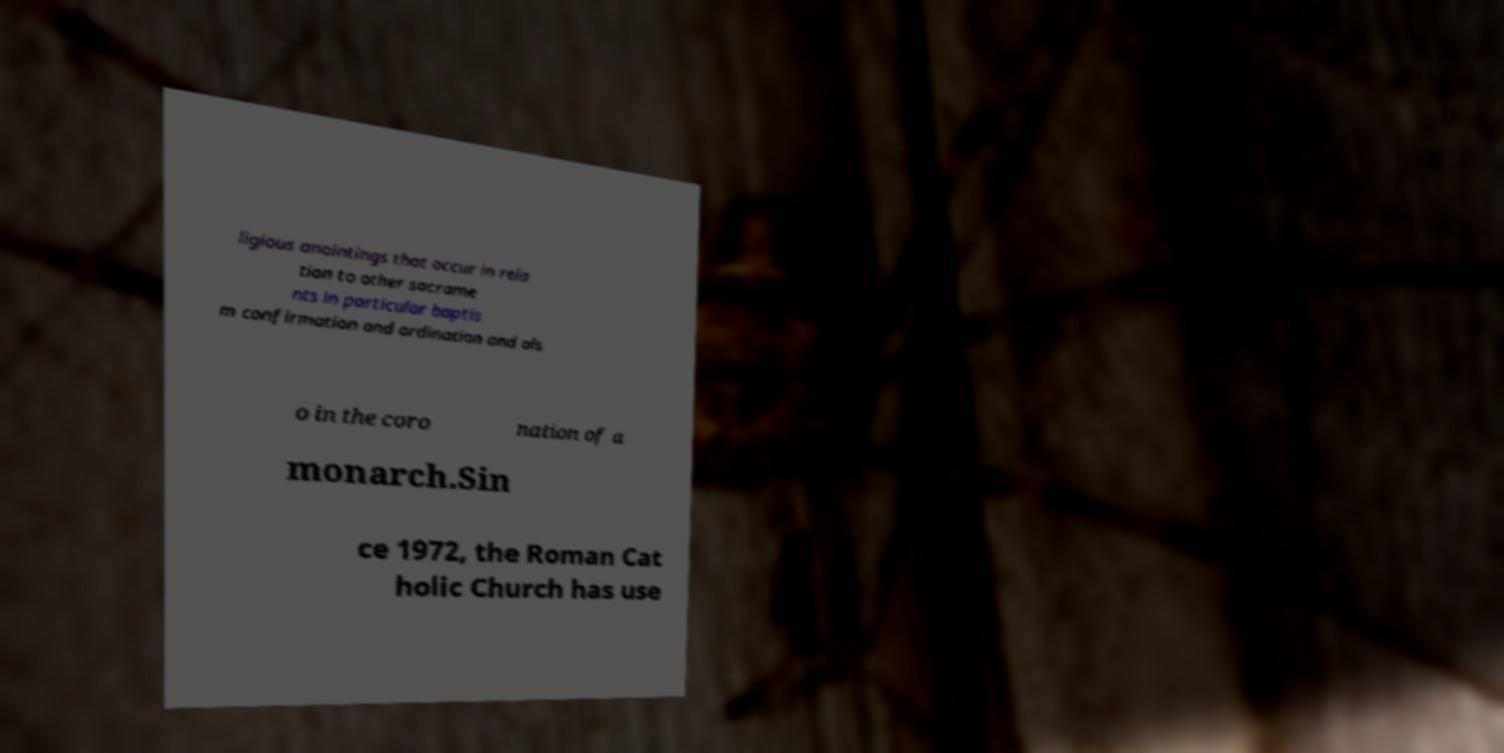Can you accurately transcribe the text from the provided image for me? ligious anointings that occur in rela tion to other sacrame nts in particular baptis m confirmation and ordination and als o in the coro nation of a monarch.Sin ce 1972, the Roman Cat holic Church has use 